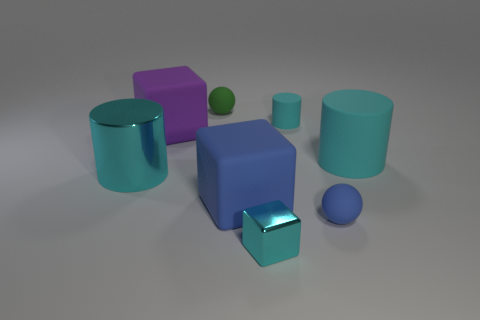There is a large metal thing that is the same color as the small block; what shape is it?
Your response must be concise. Cylinder. The other metal thing that is the same color as the small metallic thing is what size?
Your answer should be compact. Large. How many rubber things have the same color as the big metal thing?
Provide a succinct answer. 2. What is the size of the blue rubber sphere?
Your answer should be very brief. Small. Do the blue matte sphere and the purple thing have the same size?
Ensure brevity in your answer.  No. There is a cylinder that is both in front of the purple rubber block and right of the metallic cylinder; what is its color?
Provide a succinct answer. Cyan. How many small things are the same material as the tiny green sphere?
Your response must be concise. 2. What number of tiny brown matte things are there?
Keep it short and to the point. 0. Do the green rubber thing and the cylinder in front of the big rubber cylinder have the same size?
Provide a succinct answer. No. What material is the cylinder that is left of the ball behind the large blue rubber block?
Give a very brief answer. Metal. 